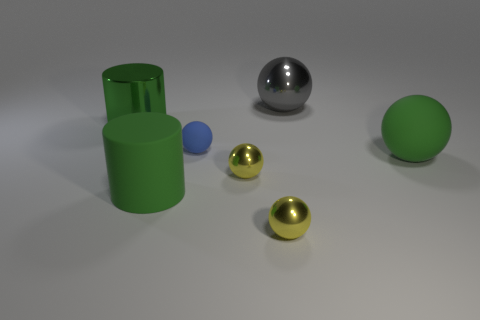Subtract all green balls. How many balls are left? 4 Subtract all large rubber balls. How many balls are left? 4 Subtract all green spheres. Subtract all gray cubes. How many spheres are left? 4 Add 3 large green metallic objects. How many objects exist? 10 Subtract all spheres. How many objects are left? 2 Subtract all gray metal blocks. Subtract all spheres. How many objects are left? 2 Add 6 big gray metallic things. How many big gray metallic things are left? 7 Add 5 big gray shiny spheres. How many big gray shiny spheres exist? 6 Subtract 1 blue balls. How many objects are left? 6 